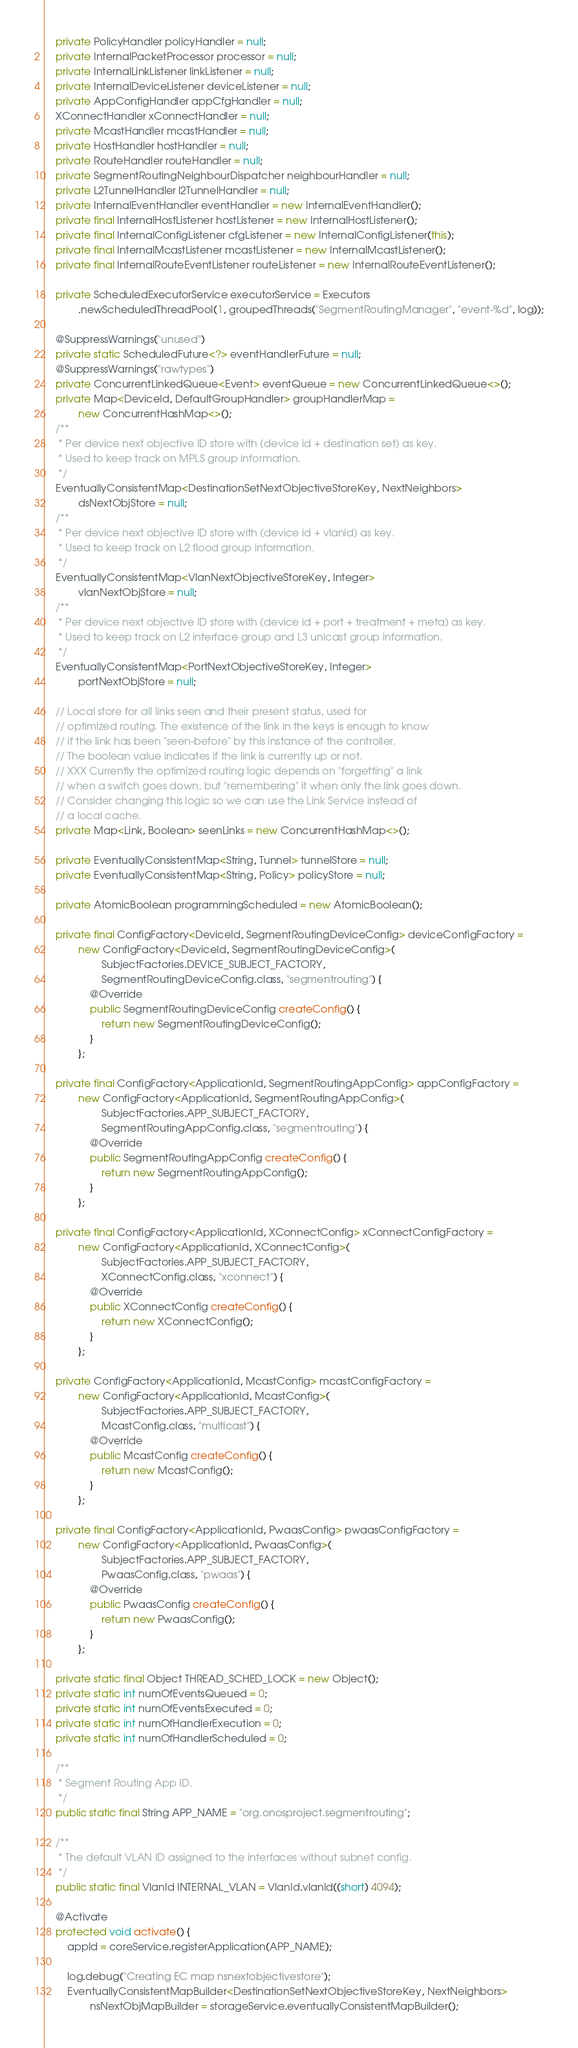Convert code to text. <code><loc_0><loc_0><loc_500><loc_500><_Java_>    private PolicyHandler policyHandler = null;
    private InternalPacketProcessor processor = null;
    private InternalLinkListener linkListener = null;
    private InternalDeviceListener deviceListener = null;
    private AppConfigHandler appCfgHandler = null;
    XConnectHandler xConnectHandler = null;
    private McastHandler mcastHandler = null;
    private HostHandler hostHandler = null;
    private RouteHandler routeHandler = null;
    private SegmentRoutingNeighbourDispatcher neighbourHandler = null;
    private L2TunnelHandler l2TunnelHandler = null;
    private InternalEventHandler eventHandler = new InternalEventHandler();
    private final InternalHostListener hostListener = new InternalHostListener();
    private final InternalConfigListener cfgListener = new InternalConfigListener(this);
    private final InternalMcastListener mcastListener = new InternalMcastListener();
    private final InternalRouteEventListener routeListener = new InternalRouteEventListener();

    private ScheduledExecutorService executorService = Executors
            .newScheduledThreadPool(1, groupedThreads("SegmentRoutingManager", "event-%d", log));

    @SuppressWarnings("unused")
    private static ScheduledFuture<?> eventHandlerFuture = null;
    @SuppressWarnings("rawtypes")
    private ConcurrentLinkedQueue<Event> eventQueue = new ConcurrentLinkedQueue<>();
    private Map<DeviceId, DefaultGroupHandler> groupHandlerMap =
            new ConcurrentHashMap<>();
    /**
     * Per device next objective ID store with (device id + destination set) as key.
     * Used to keep track on MPLS group information.
     */
    EventuallyConsistentMap<DestinationSetNextObjectiveStoreKey, NextNeighbors>
            dsNextObjStore = null;
    /**
     * Per device next objective ID store with (device id + vlanid) as key.
     * Used to keep track on L2 flood group information.
     */
    EventuallyConsistentMap<VlanNextObjectiveStoreKey, Integer>
            vlanNextObjStore = null;
    /**
     * Per device next objective ID store with (device id + port + treatment + meta) as key.
     * Used to keep track on L2 interface group and L3 unicast group information.
     */
    EventuallyConsistentMap<PortNextObjectiveStoreKey, Integer>
            portNextObjStore = null;

    // Local store for all links seen and their present status, used for
    // optimized routing. The existence of the link in the keys is enough to know
    // if the link has been "seen-before" by this instance of the controller.
    // The boolean value indicates if the link is currently up or not.
    // XXX Currently the optimized routing logic depends on "forgetting" a link
    // when a switch goes down, but "remembering" it when only the link goes down.
    // Consider changing this logic so we can use the Link Service instead of
    // a local cache.
    private Map<Link, Boolean> seenLinks = new ConcurrentHashMap<>();

    private EventuallyConsistentMap<String, Tunnel> tunnelStore = null;
    private EventuallyConsistentMap<String, Policy> policyStore = null;

    private AtomicBoolean programmingScheduled = new AtomicBoolean();

    private final ConfigFactory<DeviceId, SegmentRoutingDeviceConfig> deviceConfigFactory =
            new ConfigFactory<DeviceId, SegmentRoutingDeviceConfig>(
                    SubjectFactories.DEVICE_SUBJECT_FACTORY,
                    SegmentRoutingDeviceConfig.class, "segmentrouting") {
                @Override
                public SegmentRoutingDeviceConfig createConfig() {
                    return new SegmentRoutingDeviceConfig();
                }
            };

    private final ConfigFactory<ApplicationId, SegmentRoutingAppConfig> appConfigFactory =
            new ConfigFactory<ApplicationId, SegmentRoutingAppConfig>(
                    SubjectFactories.APP_SUBJECT_FACTORY,
                    SegmentRoutingAppConfig.class, "segmentrouting") {
                @Override
                public SegmentRoutingAppConfig createConfig() {
                    return new SegmentRoutingAppConfig();
                }
            };

    private final ConfigFactory<ApplicationId, XConnectConfig> xConnectConfigFactory =
            new ConfigFactory<ApplicationId, XConnectConfig>(
                    SubjectFactories.APP_SUBJECT_FACTORY,
                    XConnectConfig.class, "xconnect") {
                @Override
                public XConnectConfig createConfig() {
                    return new XConnectConfig();
                }
            };

    private ConfigFactory<ApplicationId, McastConfig> mcastConfigFactory =
            new ConfigFactory<ApplicationId, McastConfig>(
                    SubjectFactories.APP_SUBJECT_FACTORY,
                    McastConfig.class, "multicast") {
                @Override
                public McastConfig createConfig() {
                    return new McastConfig();
                }
            };

    private final ConfigFactory<ApplicationId, PwaasConfig> pwaasConfigFactory =
            new ConfigFactory<ApplicationId, PwaasConfig>(
                    SubjectFactories.APP_SUBJECT_FACTORY,
                    PwaasConfig.class, "pwaas") {
                @Override
                public PwaasConfig createConfig() {
                    return new PwaasConfig();
                }
            };

    private static final Object THREAD_SCHED_LOCK = new Object();
    private static int numOfEventsQueued = 0;
    private static int numOfEventsExecuted = 0;
    private static int numOfHandlerExecution = 0;
    private static int numOfHandlerScheduled = 0;

    /**
     * Segment Routing App ID.
     */
    public static final String APP_NAME = "org.onosproject.segmentrouting";

    /**
     * The default VLAN ID assigned to the interfaces without subnet config.
     */
    public static final VlanId INTERNAL_VLAN = VlanId.vlanId((short) 4094);

    @Activate
    protected void activate() {
        appId = coreService.registerApplication(APP_NAME);

        log.debug("Creating EC map nsnextobjectivestore");
        EventuallyConsistentMapBuilder<DestinationSetNextObjectiveStoreKey, NextNeighbors>
                nsNextObjMapBuilder = storageService.eventuallyConsistentMapBuilder();</code> 